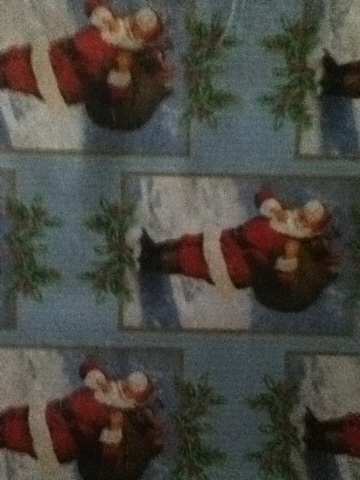What kind of event do you think this wrapping paper is most suited for? This wrapping paper is most suited for Christmas celebrations. It would be perfect for wrapping gifts that are exchanged during family gatherings, office holiday parties, or any event where Christmas presents are given. Its festive design with Santa Claus and mistletoe clearly conveys the holiday spirit. 